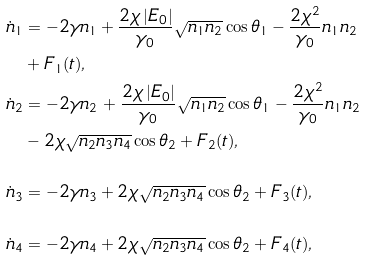Convert formula to latex. <formula><loc_0><loc_0><loc_500><loc_500>\dot { n } _ { 1 } & = - 2 \gamma n _ { 1 } + \frac { 2 \chi \left | E _ { 0 } \right | } { \gamma _ { 0 } } \sqrt { n _ { 1 } n _ { 2 } } \cos \theta _ { 1 } - \frac { 2 \chi ^ { 2 } } { \gamma _ { 0 } } n _ { 1 } n _ { 2 } \\ & + F _ { 1 } ( t ) , \\ \dot { n } _ { 2 } & = - 2 \gamma n _ { 2 } \, + \frac { 2 \chi \left | E _ { 0 } \right | } { \gamma _ { 0 } } \sqrt { n _ { 1 } n _ { 2 } } \cos \theta _ { 1 } - \frac { 2 \chi ^ { 2 } } { \gamma _ { 0 } } n _ { 1 } n _ { 2 } \\ & - 2 \chi \sqrt { n _ { 2 } n _ { 3 } n _ { 4 } } \cos \theta _ { 2 } + F _ { 2 } ( t ) , \\ \\ \dot { n } _ { 3 } & = - 2 \gamma n _ { 3 } + 2 \chi \sqrt { n _ { 2 } n _ { 3 } n _ { 4 } } \cos \theta _ { 2 } + F _ { 3 } ( t ) , \\ \\ \dot { n } _ { 4 } & = - 2 \gamma n _ { 4 } + 2 \chi \sqrt { n _ { 2 } n _ { 3 } n _ { 4 } } \cos \theta _ { 2 } + F _ { 4 } ( t ) ,</formula> 